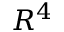<formula> <loc_0><loc_0><loc_500><loc_500>R ^ { 4 }</formula> 